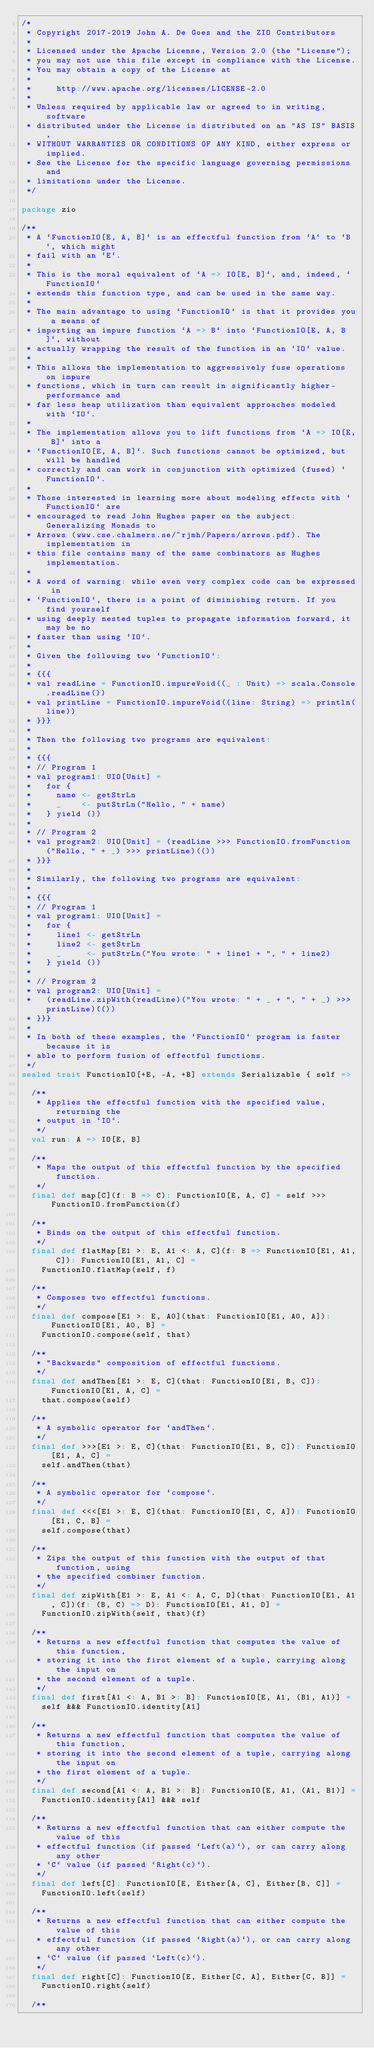<code> <loc_0><loc_0><loc_500><loc_500><_Scala_>/*
 * Copyright 2017-2019 John A. De Goes and the ZIO Contributors
 *
 * Licensed under the Apache License, Version 2.0 (the "License");
 * you may not use this file except in compliance with the License.
 * You may obtain a copy of the License at
 *
 *     http://www.apache.org/licenses/LICENSE-2.0
 *
 * Unless required by applicable law or agreed to in writing, software
 * distributed under the License is distributed on an "AS IS" BASIS,
 * WITHOUT WARRANTIES OR CONDITIONS OF ANY KIND, either express or implied.
 * See the License for the specific language governing permissions and
 * limitations under the License.
 */

package zio

/**
 * A `FunctionIO[E, A, B]` is an effectful function from `A` to `B`, which might
 * fail with an `E`.
 *
 * This is the moral equivalent of `A => IO[E, B]`, and, indeed, `FunctionIO`
 * extends this function type, and can be used in the same way.
 *
 * The main advantage to using `FunctionIO` is that it provides you a means of
 * importing an impure function `A => B` into `FunctionIO[E, A, B]`, without
 * actually wrapping the result of the function in an `IO` value.
 *
 * This allows the implementation to aggressively fuse operations on impure
 * functions, which in turn can result in significantly higher-performance and
 * far less heap utilization than equivalent approaches modeled with `IO`.
 *
 * The implementation allows you to lift functions from `A => IO[E, B]` into a
 * `FunctionIO[E, A, B]`. Such functions cannot be optimized, but will be handled
 * correctly and can work in conjunction with optimized (fused) `FunctionIO`.
 *
 * Those interested in learning more about modeling effects with `FunctionIO` are
 * encouraged to read John Hughes paper on the subject: Generalizing Monads to
 * Arrows (www.cse.chalmers.se/~rjmh/Papers/arrows.pdf). The implementation in
 * this file contains many of the same combinators as Hughes implementation.
 *
 * A word of warning: while even very complex code can be expressed in
 * `FunctionIO`, there is a point of diminishing return. If you find yourself
 * using deeply nested tuples to propagate information forward, it may be no
 * faster than using `IO`.
 *
 * Given the following two `FunctionIO`:
 *
 * {{{
 * val readLine = FunctionIO.impureVoid((_ : Unit) => scala.Console.readLine())
 * val printLine = FunctionIO.impureVoid((line: String) => println(line))
 * }}}
 *
 * Then the following two programs are equivalent:
 *
 * {{{
 * // Program 1
 * val program1: UIO[Unit] =
 *   for {
 *     name <- getStrLn
 *     _    <- putStrLn("Hello, " + name)
 *   } yield ())
 *
 * // Program 2
 * val program2: UIO[Unit] = (readLine >>> FunctionIO.fromFunction("Hello, " + _) >>> printLine)(())
 * }}}
 *
 * Similarly, the following two programs are equivalent:
 *
 * {{{
 * // Program 1
 * val program1: UIO[Unit] =
 *   for {
 *     line1 <- getStrLn
 *     line2 <- getStrLn
 *     _     <- putStrLn("You wrote: " + line1 + ", " + line2)
 *   } yield ())
 *
 * // Program 2
 * val program2: UIO[Unit] =
 *   (readLine.zipWith(readLine)("You wrote: " + _ + ", " + _) >>> printLine)(())
 * }}}
 *
 * In both of these examples, the `FunctionIO` program is faster because it is
 * able to perform fusion of effectful functions.
 */
sealed trait FunctionIO[+E, -A, +B] extends Serializable { self =>

  /**
   * Applies the effectful function with the specified value, returning the
   * output in `IO`.
   */
  val run: A => IO[E, B]

  /**
   * Maps the output of this effectful function by the specified function.
   */
  final def map[C](f: B => C): FunctionIO[E, A, C] = self >>> FunctionIO.fromFunction(f)

  /**
   * Binds on the output of this effectful function.
   */
  final def flatMap[E1 >: E, A1 <: A, C](f: B => FunctionIO[E1, A1, C]): FunctionIO[E1, A1, C] =
    FunctionIO.flatMap(self, f)

  /**
   * Composes two effectful functions.
   */
  final def compose[E1 >: E, A0](that: FunctionIO[E1, A0, A]): FunctionIO[E1, A0, B] =
    FunctionIO.compose(self, that)

  /**
   * "Backwards" composition of effectful functions.
   */
  final def andThen[E1 >: E, C](that: FunctionIO[E1, B, C]): FunctionIO[E1, A, C] =
    that.compose(self)

  /**
   * A symbolic operator for `andThen`.
   */
  final def >>>[E1 >: E, C](that: FunctionIO[E1, B, C]): FunctionIO[E1, A, C] =
    self.andThen(that)

  /**
   * A symbolic operator for `compose`.
   */
  final def <<<[E1 >: E, C](that: FunctionIO[E1, C, A]): FunctionIO[E1, C, B] =
    self.compose(that)

  /**
   * Zips the output of this function with the output of that function, using
   * the specified combiner function.
   */
  final def zipWith[E1 >: E, A1 <: A, C, D](that: FunctionIO[E1, A1, C])(f: (B, C) => D): FunctionIO[E1, A1, D] =
    FunctionIO.zipWith(self, that)(f)

  /**
   * Returns a new effectful function that computes the value of this function,
   * storing it into the first element of a tuple, carrying along the input on
   * the second element of a tuple.
   */
  final def first[A1 <: A, B1 >: B]: FunctionIO[E, A1, (B1, A1)] =
    self &&& FunctionIO.identity[A1]

  /**
   * Returns a new effectful function that computes the value of this function,
   * storing it into the second element of a tuple, carrying along the input on
   * the first element of a tuple.
   */
  final def second[A1 <: A, B1 >: B]: FunctionIO[E, A1, (A1, B1)] =
    FunctionIO.identity[A1] &&& self

  /**
   * Returns a new effectful function that can either compute the value of this
   * effectful function (if passed `Left(a)`), or can carry along any other
   * `C` value (if passed `Right(c)`).
   */
  final def left[C]: FunctionIO[E, Either[A, C], Either[B, C]] =
    FunctionIO.left(self)

  /**
   * Returns a new effectful function that can either compute the value of this
   * effectful function (if passed `Right(a)`), or can carry along any other
   * `C` value (if passed `Left(c)`).
   */
  final def right[C]: FunctionIO[E, Either[C, A], Either[C, B]] =
    FunctionIO.right(self)

  /**</code> 